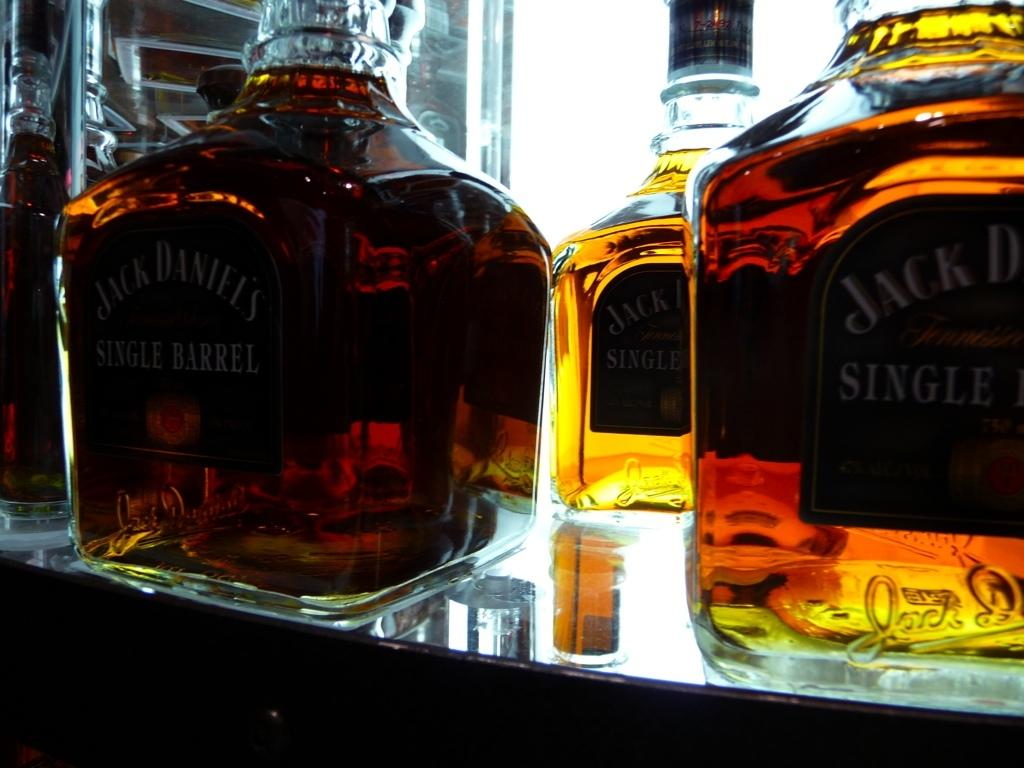<image>
Relay a brief, clear account of the picture shown. Multiple bottles of Jack Daniels alcohol placed on a counter top. 